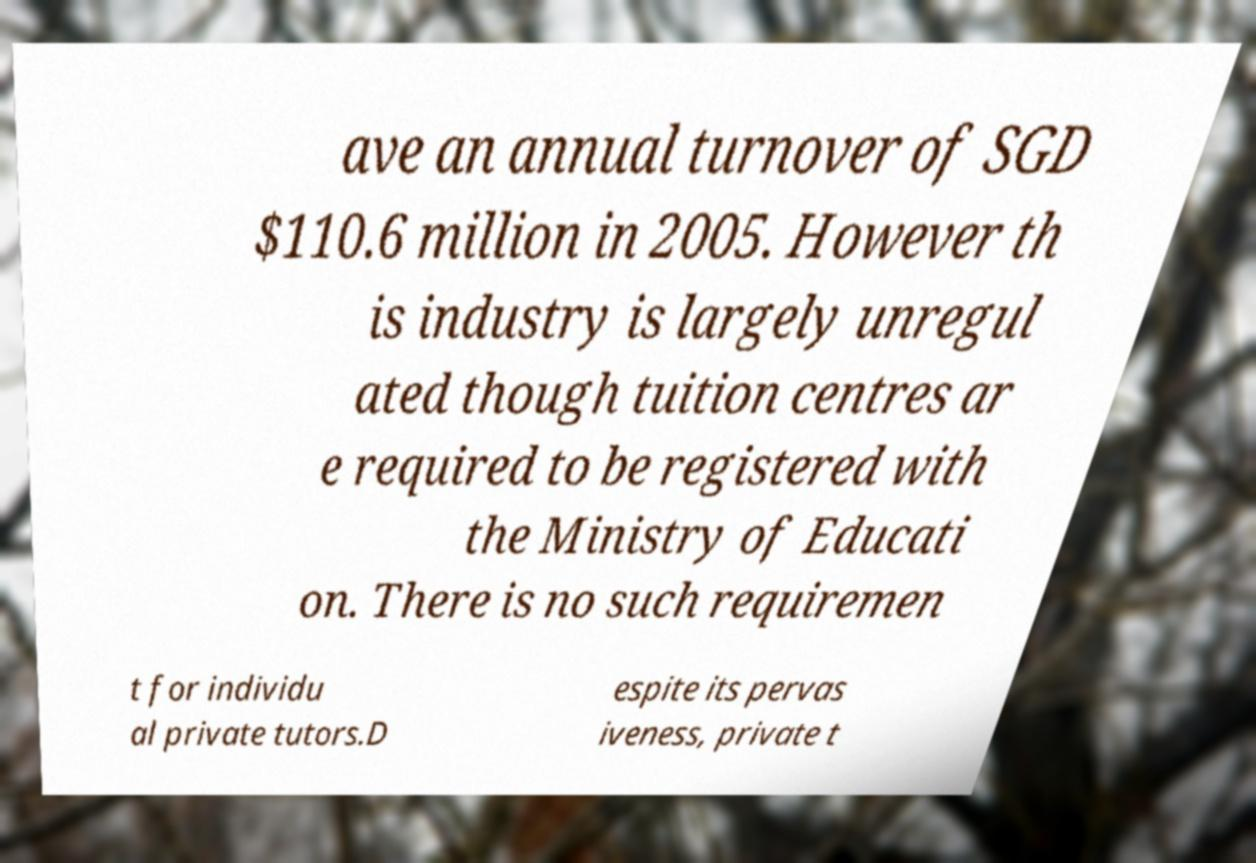Please identify and transcribe the text found in this image. ave an annual turnover of SGD $110.6 million in 2005. However th is industry is largely unregul ated though tuition centres ar e required to be registered with the Ministry of Educati on. There is no such requiremen t for individu al private tutors.D espite its pervas iveness, private t 